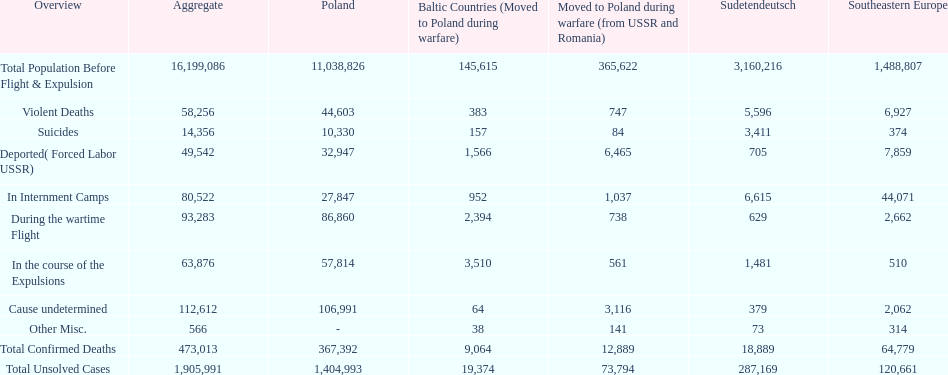Would you be able to parse every entry in this table? {'header': ['Overview', 'Aggregate', 'Poland', 'Baltic Countries (Moved to Poland during warfare)', 'Moved to Poland during warfare (from USSR and Romania)', 'Sudetendeutsch', 'Southeastern Europe'], 'rows': [['Total Population Before Flight & Expulsion', '16,199,086', '11,038,826', '145,615', '365,622', '3,160,216', '1,488,807'], ['Violent Deaths', '58,256', '44,603', '383', '747', '5,596', '6,927'], ['Suicides', '14,356', '10,330', '157', '84', '3,411', '374'], ['Deported( Forced Labor USSR)', '49,542', '32,947', '1,566', '6,465', '705', '7,859'], ['In Internment Camps', '80,522', '27,847', '952', '1,037', '6,615', '44,071'], ['During the wartime Flight', '93,283', '86,860', '2,394', '738', '629', '2,662'], ['In the course of the Expulsions', '63,876', '57,814', '3,510', '561', '1,481', '510'], ['Cause undetermined', '112,612', '106,991', '64', '3,116', '379', '2,062'], ['Other Misc.', '566', '-', '38', '141', '73', '314'], ['Total Confirmed Deaths', '473,013', '367,392', '9,064', '12,889', '18,889', '64,779'], ['Total Unsolved Cases', '1,905,991', '1,404,993', '19,374', '73,794', '287,169', '120,661']]} Were there any places without violent fatalities? No. 